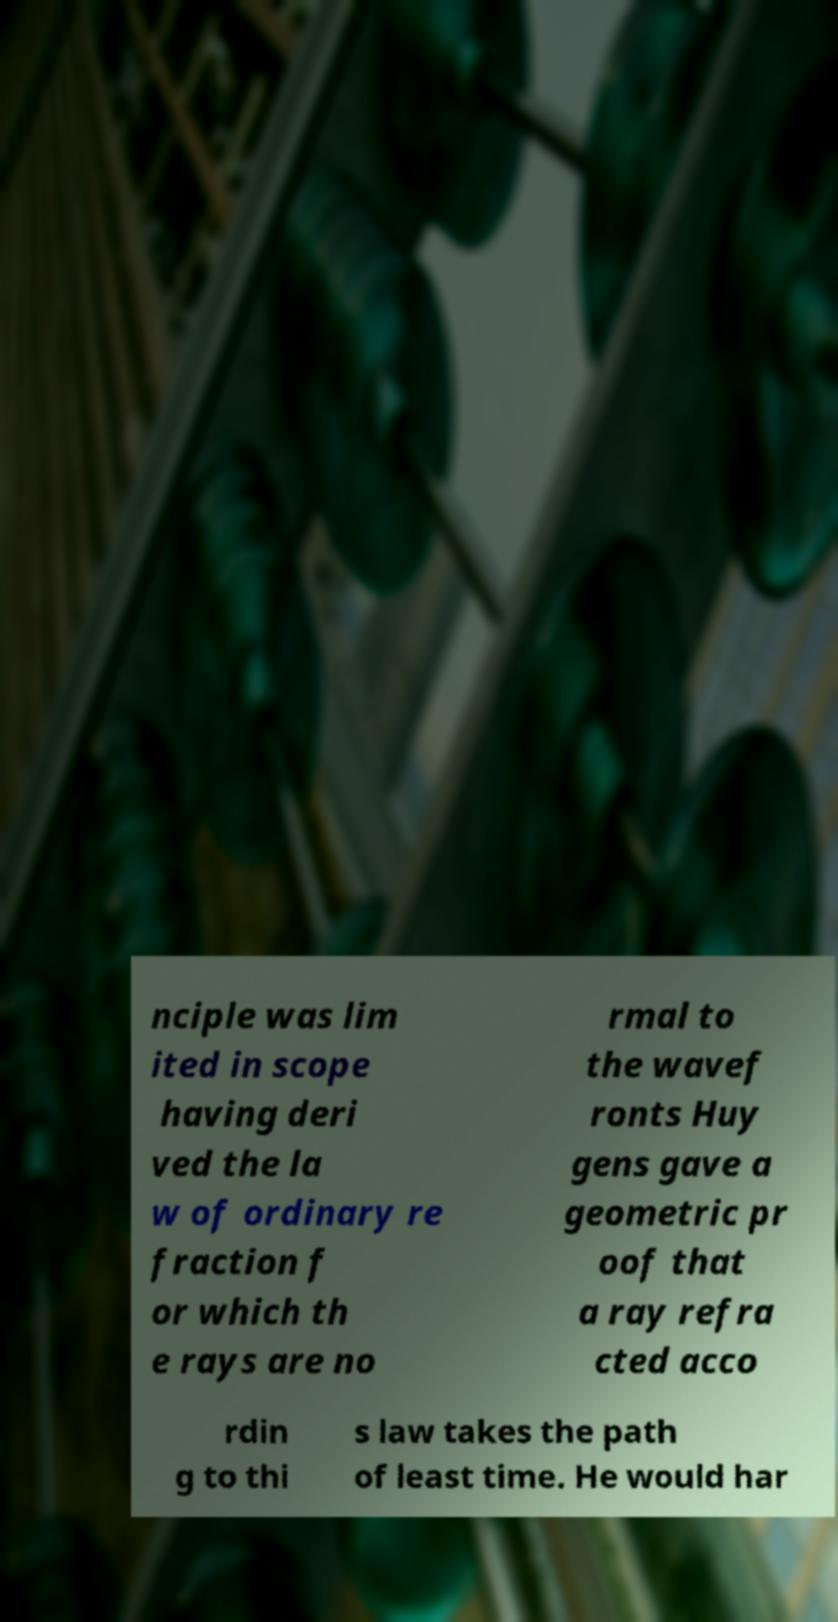Can you accurately transcribe the text from the provided image for me? nciple was lim ited in scope having deri ved the la w of ordinary re fraction f or which th e rays are no rmal to the wavef ronts Huy gens gave a geometric pr oof that a ray refra cted acco rdin g to thi s law takes the path of least time. He would har 